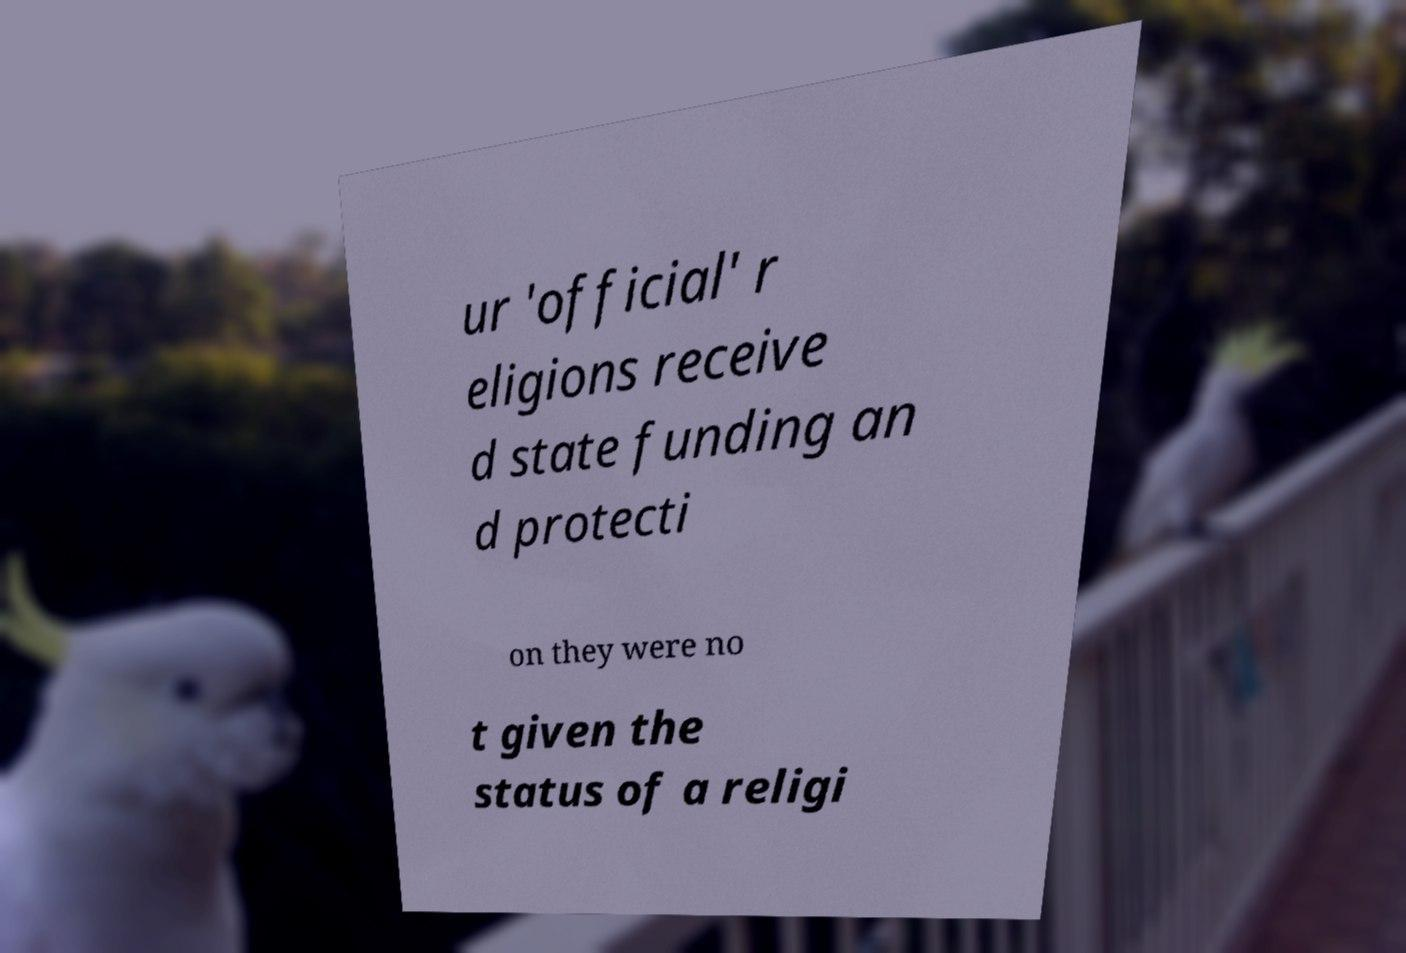For documentation purposes, I need the text within this image transcribed. Could you provide that? ur 'official' r eligions receive d state funding an d protecti on they were no t given the status of a religi 